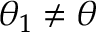<formula> <loc_0><loc_0><loc_500><loc_500>\theta _ { 1 } \neq \theta</formula> 